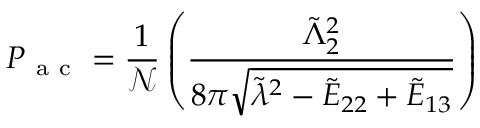<formula> <loc_0><loc_0><loc_500><loc_500>P _ { a c } = \frac { 1 } { \mathcal { N } } \left ( \frac { \tilde { \Lambda } _ { 2 } ^ { 2 } } { 8 \pi \sqrt { \tilde { \lambda } ^ { 2 } - \tilde { E } _ { 2 2 } + \tilde { E } _ { 1 3 } } } \right )</formula> 